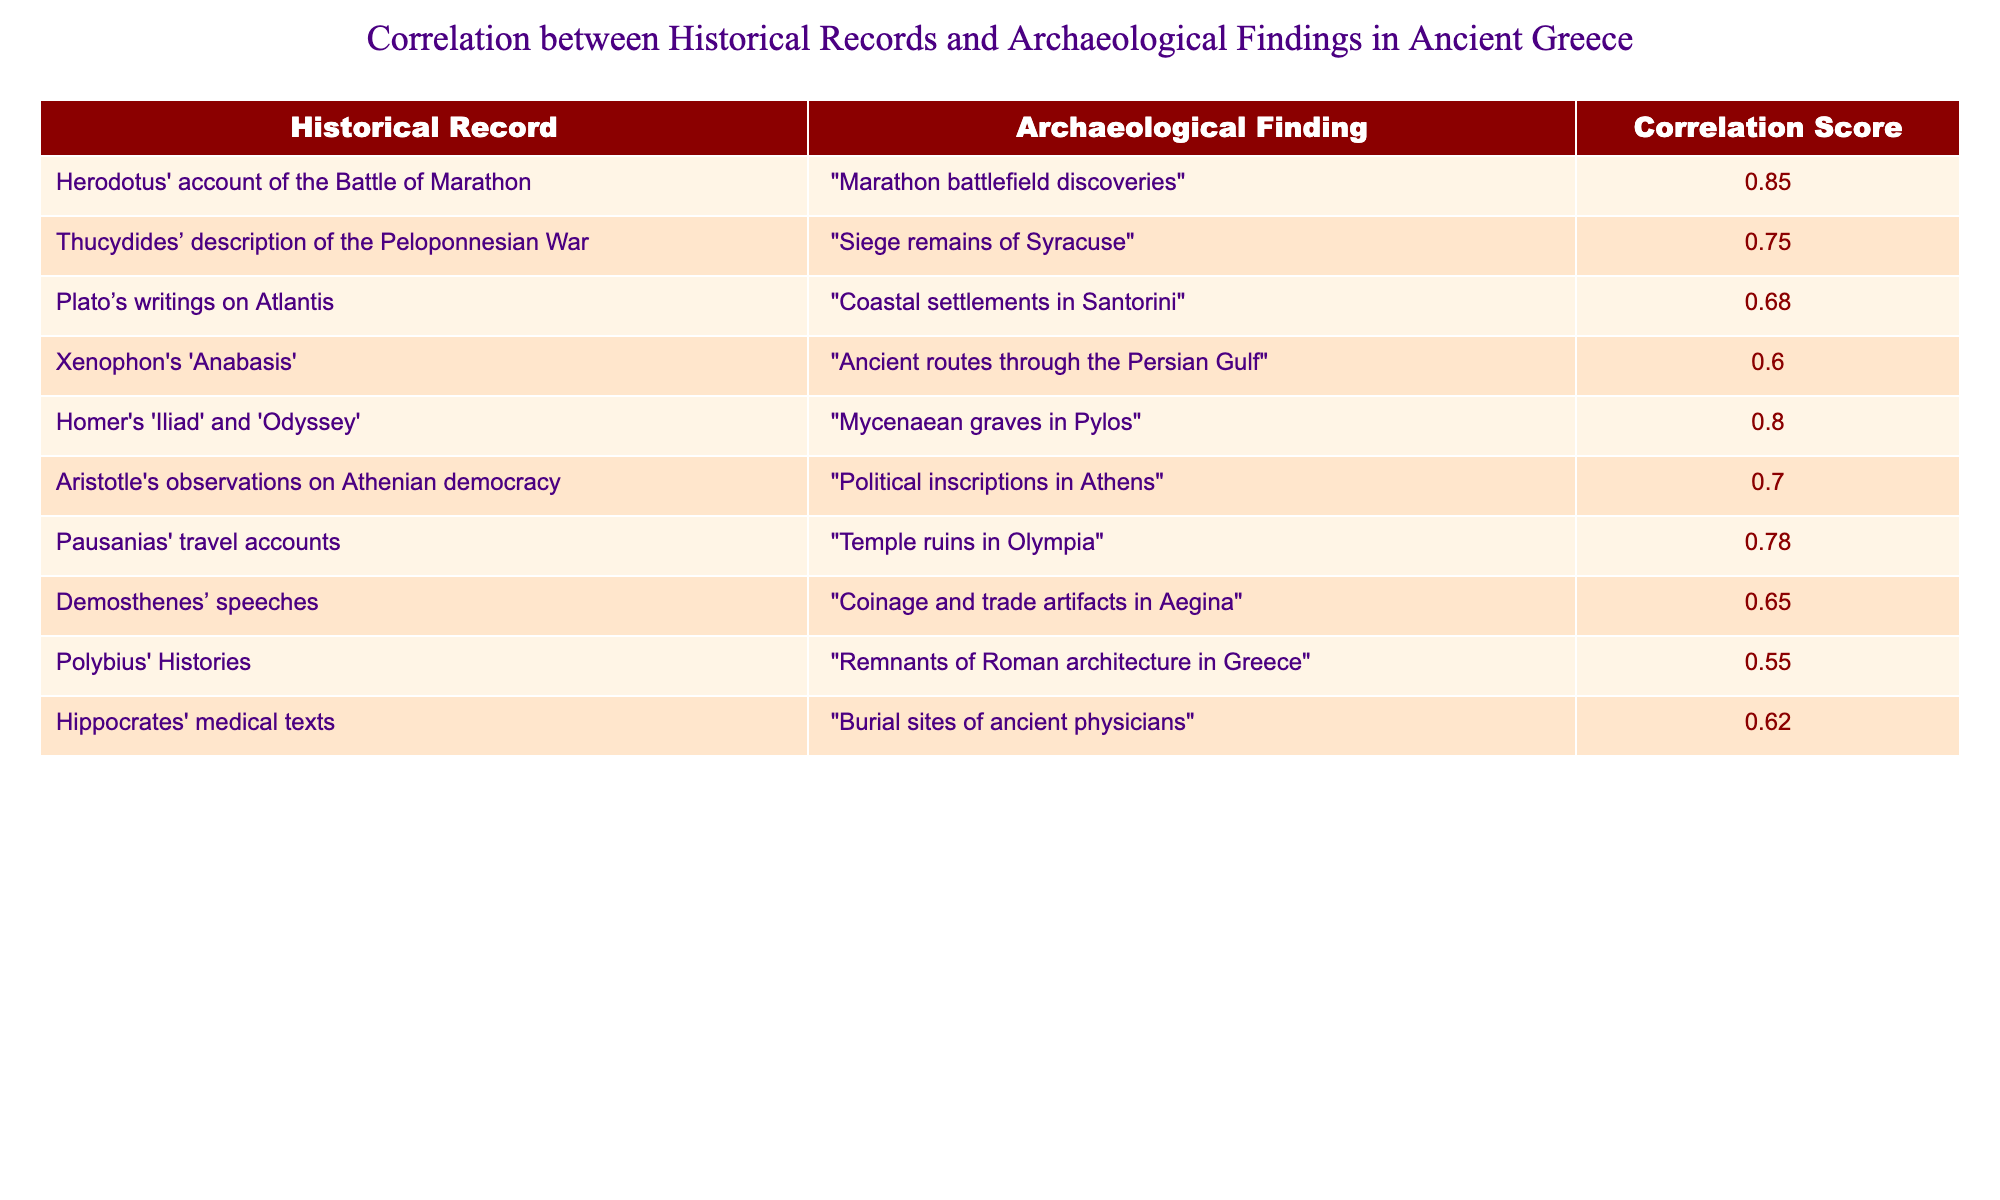What is the correlation score for Herodotus' account of the Battle of Marathon? The table shows that the correlation score for Herodotus' account of the Battle of Marathon is 0.85.
Answer: 0.85 What archaeological finding corresponds to Thucydides’ description of the Peloponnesian War? According to the table, Thucydides’ description of the Peloponnesian War corresponds to the archaeological finding of the siege remains of Syracuse.
Answer: Siege remains of Syracuse Which historical record has a correlation score higher than 0.75? The records that have a correlation score higher than 0.75 are Herodotus' account of the Battle of Marathon (0.85), Homer's 'Iliad' and 'Odyssey' (0.80), and Pausanias' travel accounts (0.78).
Answer: Herodotus' account of the Battle of Marathon, Homer's 'Iliad' and 'Odyssey', Pausanias' travel accounts What is the average correlation score of all the historical records listed? To calculate the average, we sum the correlation scores: 0.85 + 0.75 + 0.68 + 0.60 + 0.80 + 0.70 + 0.78 + 0.65 + 0.55 + 0.62 = 7.05. There are 10 records, so the average is 7.05 / 10 = 0.705.
Answer: 0.705 Is there a historical record correlated with archaeological findings related to medical practices? Yes, Hippocrates' medical texts are correlated with burial sites of ancient physicians, as indicated in the table.
Answer: Yes Which historical record has the lowest correlation score, and what is that score? The table indicates that Polybius' Histories has the lowest correlation score at 0.55.
Answer: Polybius' Histories, 0.55 How many historical records have correlation scores of 0.70 or higher? The records with scores of 0.70 or higher are Herodotus' account (0.85), Homer's works (0.80), Pausanias' accounts (0.78), Aristotle's observations (0.70) and Thucydides' description (0.75). This totals to five records.
Answer: 5 If we consider only those historical records with a correlation score above 0.65, what percentage does that represent of the total records listed? The records above a score of 0.65 are: Herodotus' (0.85), Thucydides' (0.75), Homer’s (0.80), Pausanias' (0.78), Aristotle's (0.70), and Hippocrates' (0.62). That's six out of ten records, which is (6/10) * 100 = 60%.
Answer: 60% 